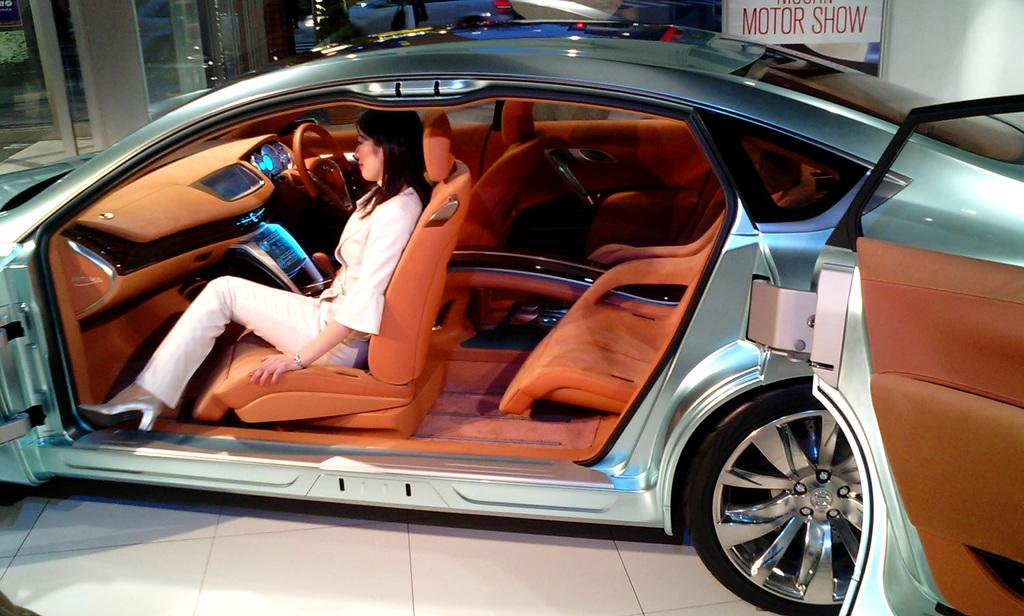What is the main subject of the picture? The main subject of the picture is a car. Who is inside the car? A woman is seated in the car. What is the position of the car doors? The car doors are opened. What else can be seen in the image besides the car and the woman? There is a board with some text in the image. What type of location might this image be depicting? The setting appears to be a showroom. What type of star is visible in the image? There is no star visible in the image; it is set in a showroom with a car and a woman. 